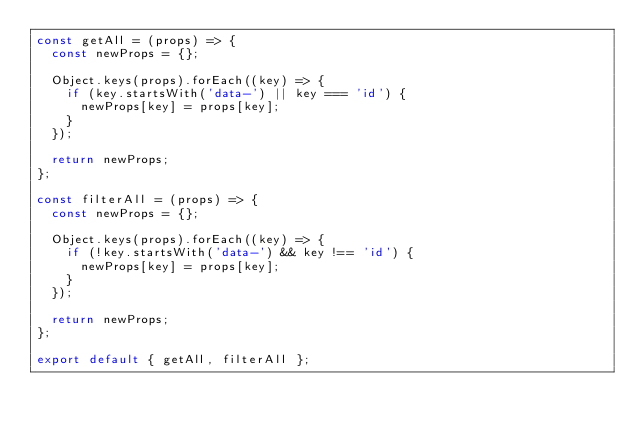Convert code to text. <code><loc_0><loc_0><loc_500><loc_500><_JavaScript_>const getAll = (props) => {
  const newProps = {};

  Object.keys(props).forEach((key) => {
    if (key.startsWith('data-') || key === 'id') {
      newProps[key] = props[key];
    }
  });

  return newProps;
};

const filterAll = (props) => {
  const newProps = {};

  Object.keys(props).forEach((key) => {
    if (!key.startsWith('data-') && key !== 'id') {
      newProps[key] = props[key];
    }
  });

  return newProps;
};

export default { getAll, filterAll };
</code> 